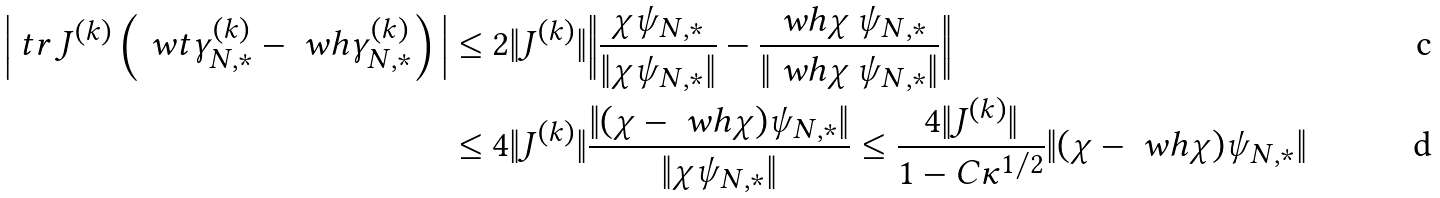Convert formula to latex. <formula><loc_0><loc_0><loc_500><loc_500>\Big | \ t r \, J ^ { ( k ) } \left ( \ w t \gamma ^ { ( k ) } _ { N , * } - \ w h \gamma ^ { ( k ) } _ { N , * } \right ) \Big | & \leq 2 \| J ^ { ( k ) } \| \Big { \| } \frac { \chi \psi _ { N , * } } { \| \chi \psi _ { N , * } \| } - \frac { \ w h \chi \, \psi _ { N , * } } { \| \ w h \chi \, \psi _ { N , * } \| } \Big \| \\ & \leq 4 \| J ^ { ( k ) } \| \frac { \| ( \chi - \ w h \chi ) \psi _ { N , * } \| } { \| \chi \psi _ { N , * } \| } \leq \frac { 4 \| J ^ { ( k ) } \| } { 1 - C \kappa ^ { 1 / 2 } } \| ( \chi - \ w h \chi ) \psi _ { N , * } \|</formula> 